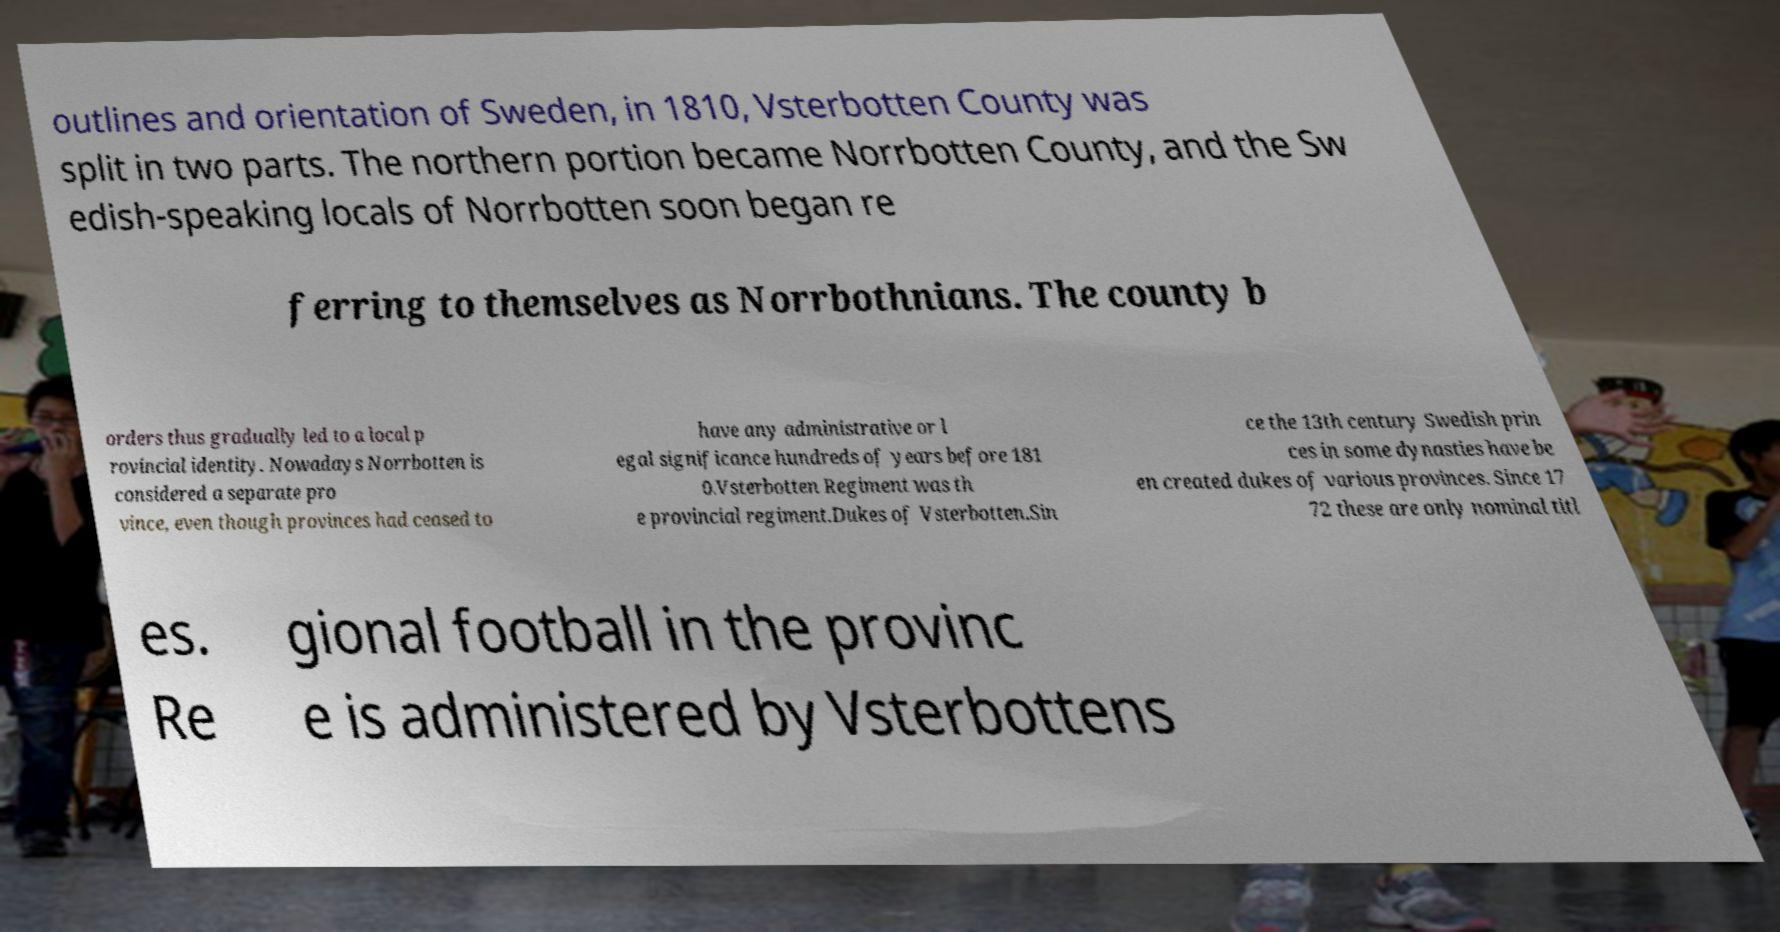I need the written content from this picture converted into text. Can you do that? outlines and orientation of Sweden, in 1810, Vsterbotten County was split in two parts. The northern portion became Norrbotten County, and the Sw edish-speaking locals of Norrbotten soon began re ferring to themselves as Norrbothnians. The county b orders thus gradually led to a local p rovincial identity. Nowadays Norrbotten is considered a separate pro vince, even though provinces had ceased to have any administrative or l egal significance hundreds of years before 181 0.Vsterbotten Regiment was th e provincial regiment.Dukes of Vsterbotten.Sin ce the 13th century Swedish prin ces in some dynasties have be en created dukes of various provinces. Since 17 72 these are only nominal titl es. Re gional football in the provinc e is administered by Vsterbottens 